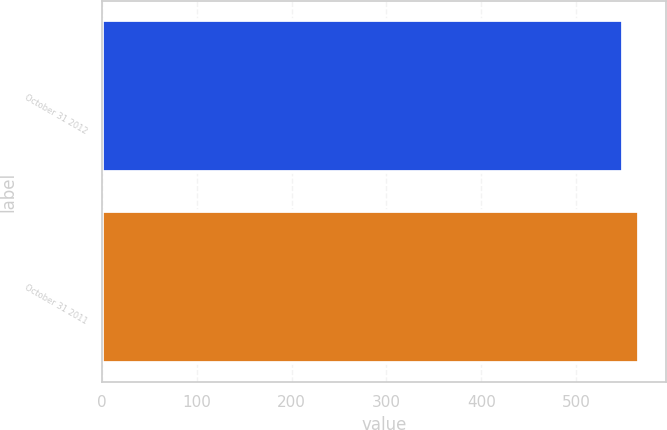<chart> <loc_0><loc_0><loc_500><loc_500><bar_chart><fcel>October 31 2012<fcel>October 31 2011<nl><fcel>550<fcel>567<nl></chart> 